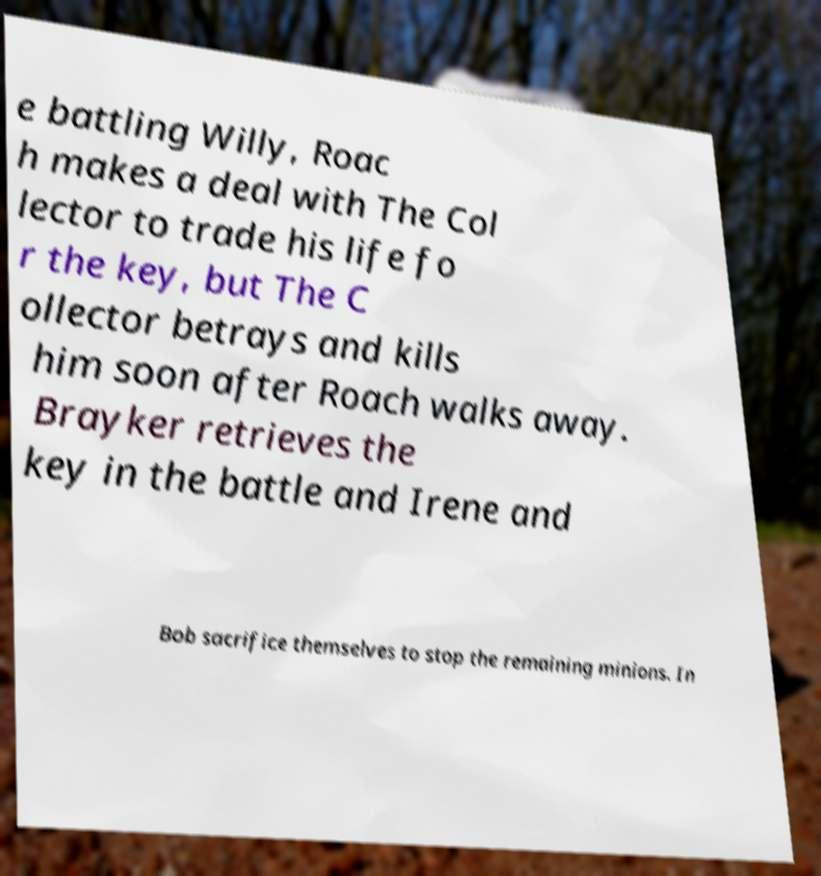What messages or text are displayed in this image? I need them in a readable, typed format. e battling Willy, Roac h makes a deal with The Col lector to trade his life fo r the key, but The C ollector betrays and kills him soon after Roach walks away. Brayker retrieves the key in the battle and Irene and Bob sacrifice themselves to stop the remaining minions. In 